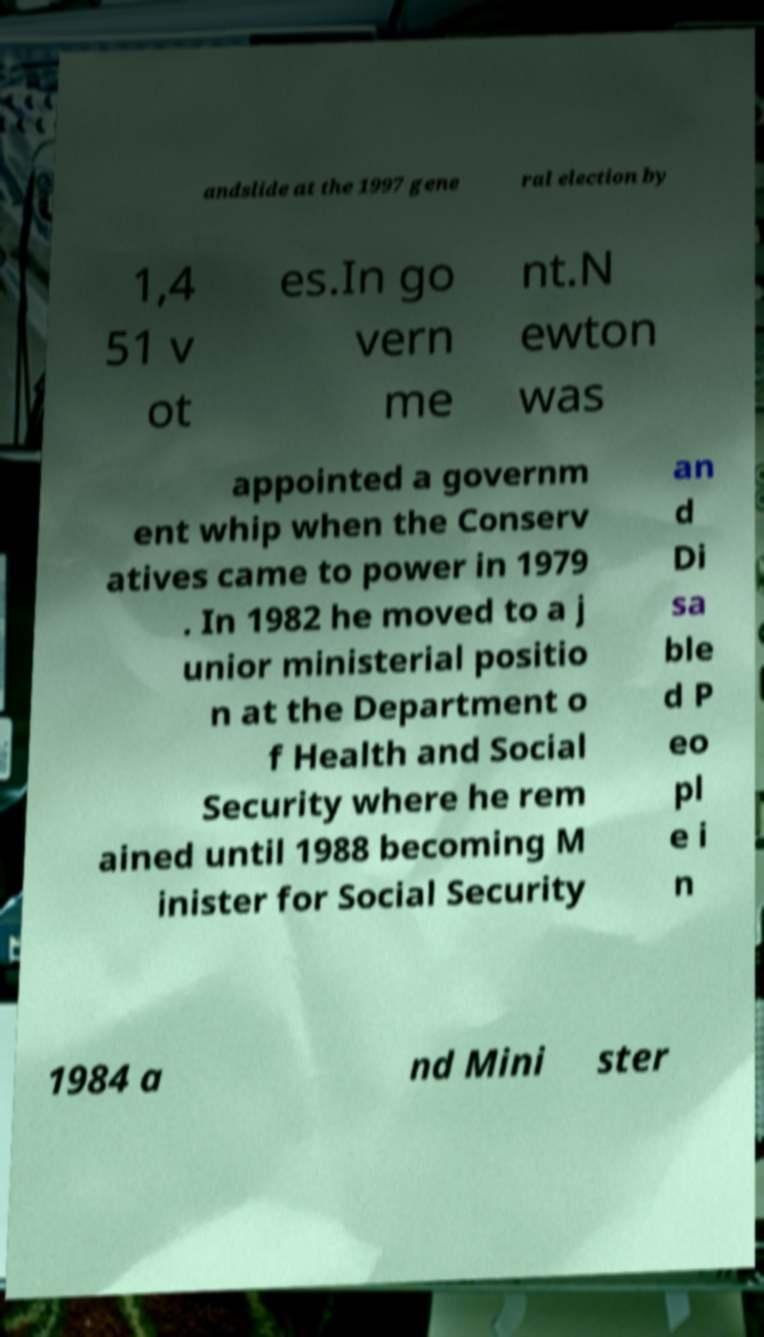Could you extract and type out the text from this image? andslide at the 1997 gene ral election by 1,4 51 v ot es.In go vern me nt.N ewton was appointed a governm ent whip when the Conserv atives came to power in 1979 . In 1982 he moved to a j unior ministerial positio n at the Department o f Health and Social Security where he rem ained until 1988 becoming M inister for Social Security an d Di sa ble d P eo pl e i n 1984 a nd Mini ster 